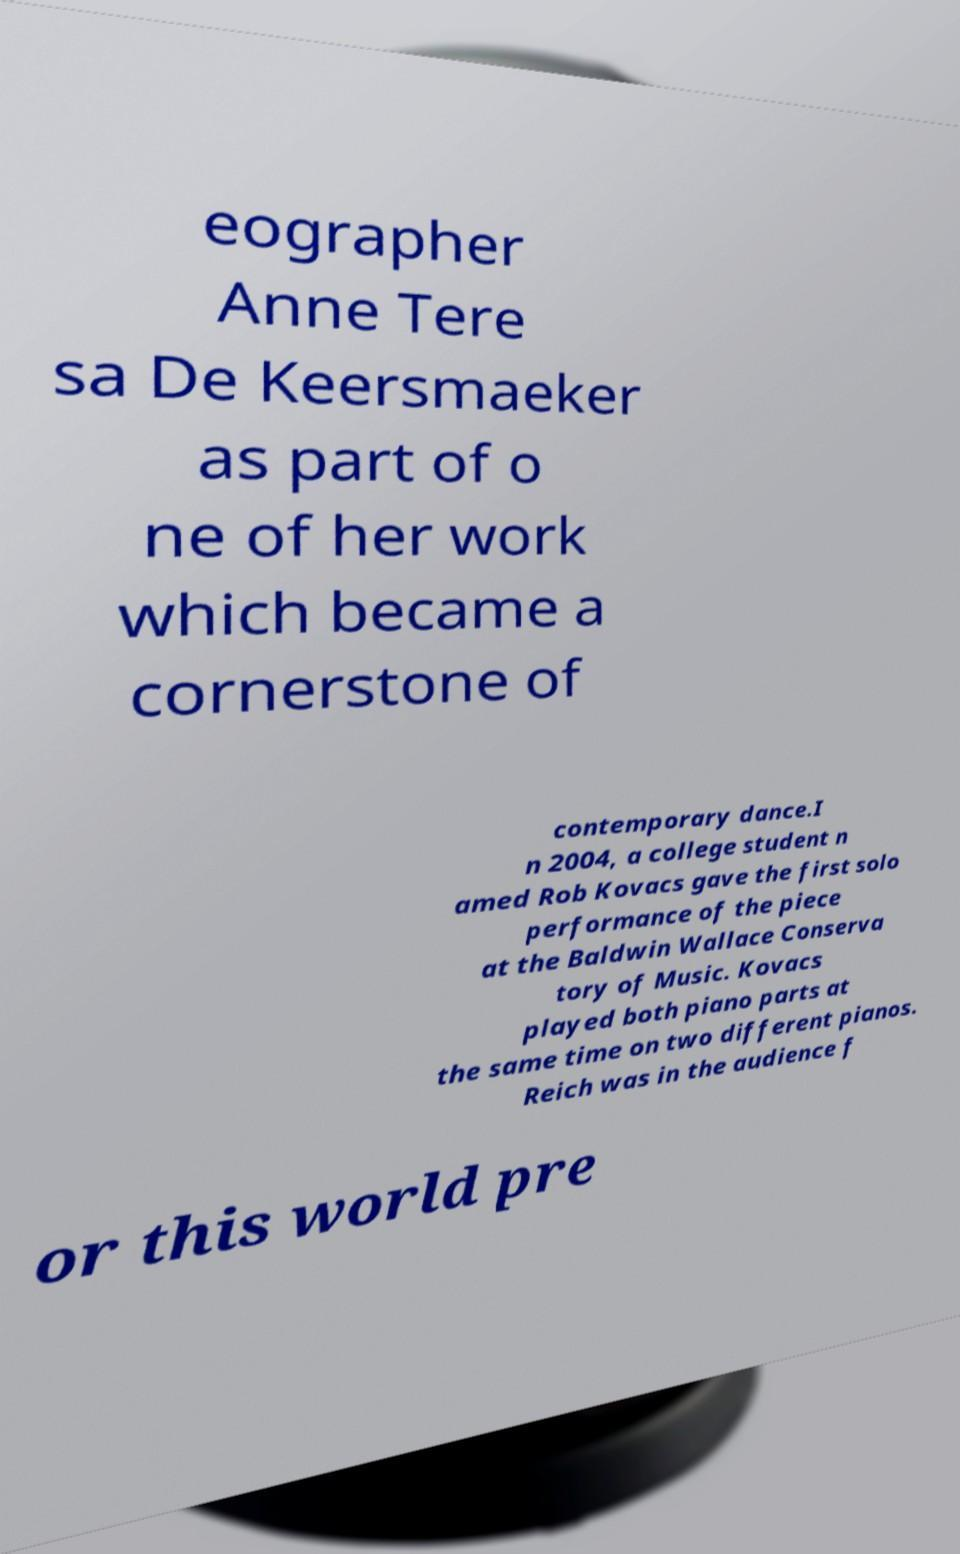Could you extract and type out the text from this image? eographer Anne Tere sa De Keersmaeker as part of o ne of her work which became a cornerstone of contemporary dance.I n 2004, a college student n amed Rob Kovacs gave the first solo performance of the piece at the Baldwin Wallace Conserva tory of Music. Kovacs played both piano parts at the same time on two different pianos. Reich was in the audience f or this world pre 